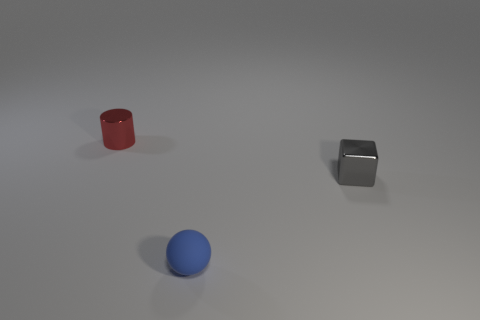Is the number of balls in front of the tiny red metallic object greater than the number of small blue objects that are on the right side of the gray shiny thing? No, the number of balls in front of the tiny red metallic object, which is one, is not greater than the number of small blue objects to the right of the gray shiny thing, as there is only one blue object visible in the image. 